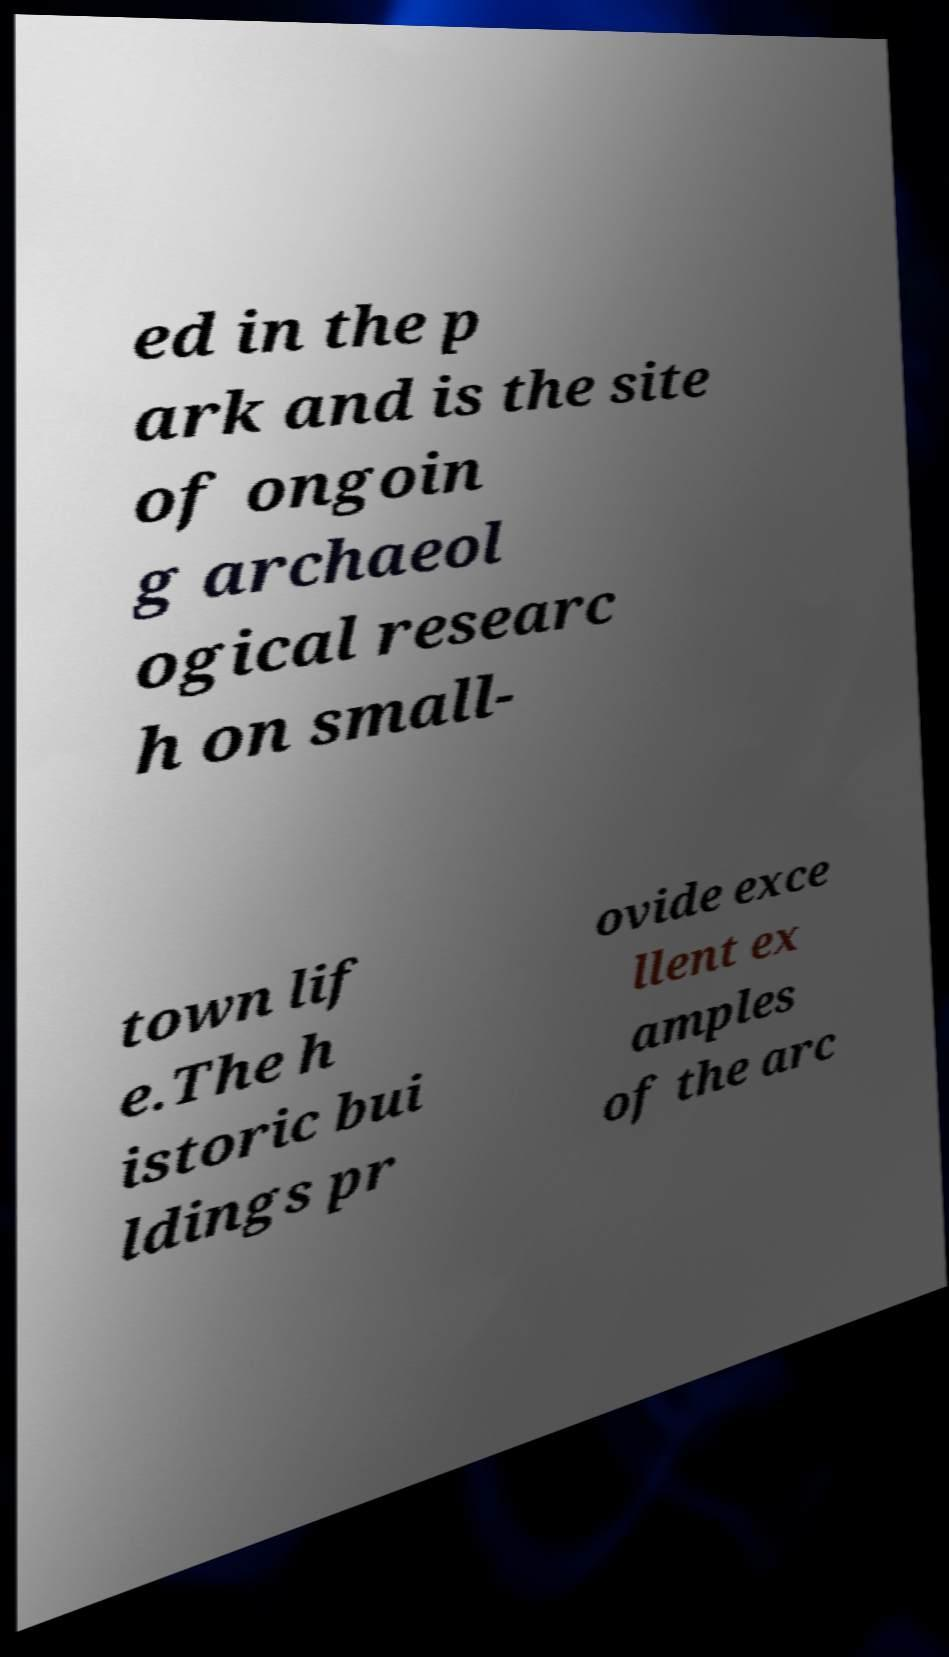Please identify and transcribe the text found in this image. ed in the p ark and is the site of ongoin g archaeol ogical researc h on small- town lif e.The h istoric bui ldings pr ovide exce llent ex amples of the arc 